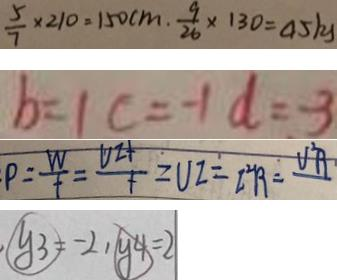Convert formula to latex. <formula><loc_0><loc_0><loc_500><loc_500>\frac { 5 } { 7 } \times 2 1 0 = 1 5 0 c m . \frac { 9 } { 2 6 } \times 1 3 0 = 4 5 k 
 b = 1 c = - 1 d = - 3 
 P = \frac { W } { f } = \frac { V Z f } { f } = U Z = I ^ { 2 } R = V ^ { 2 } R 
 y _ { 3 } = - 2 , y _ { 4 } = 2</formula> 